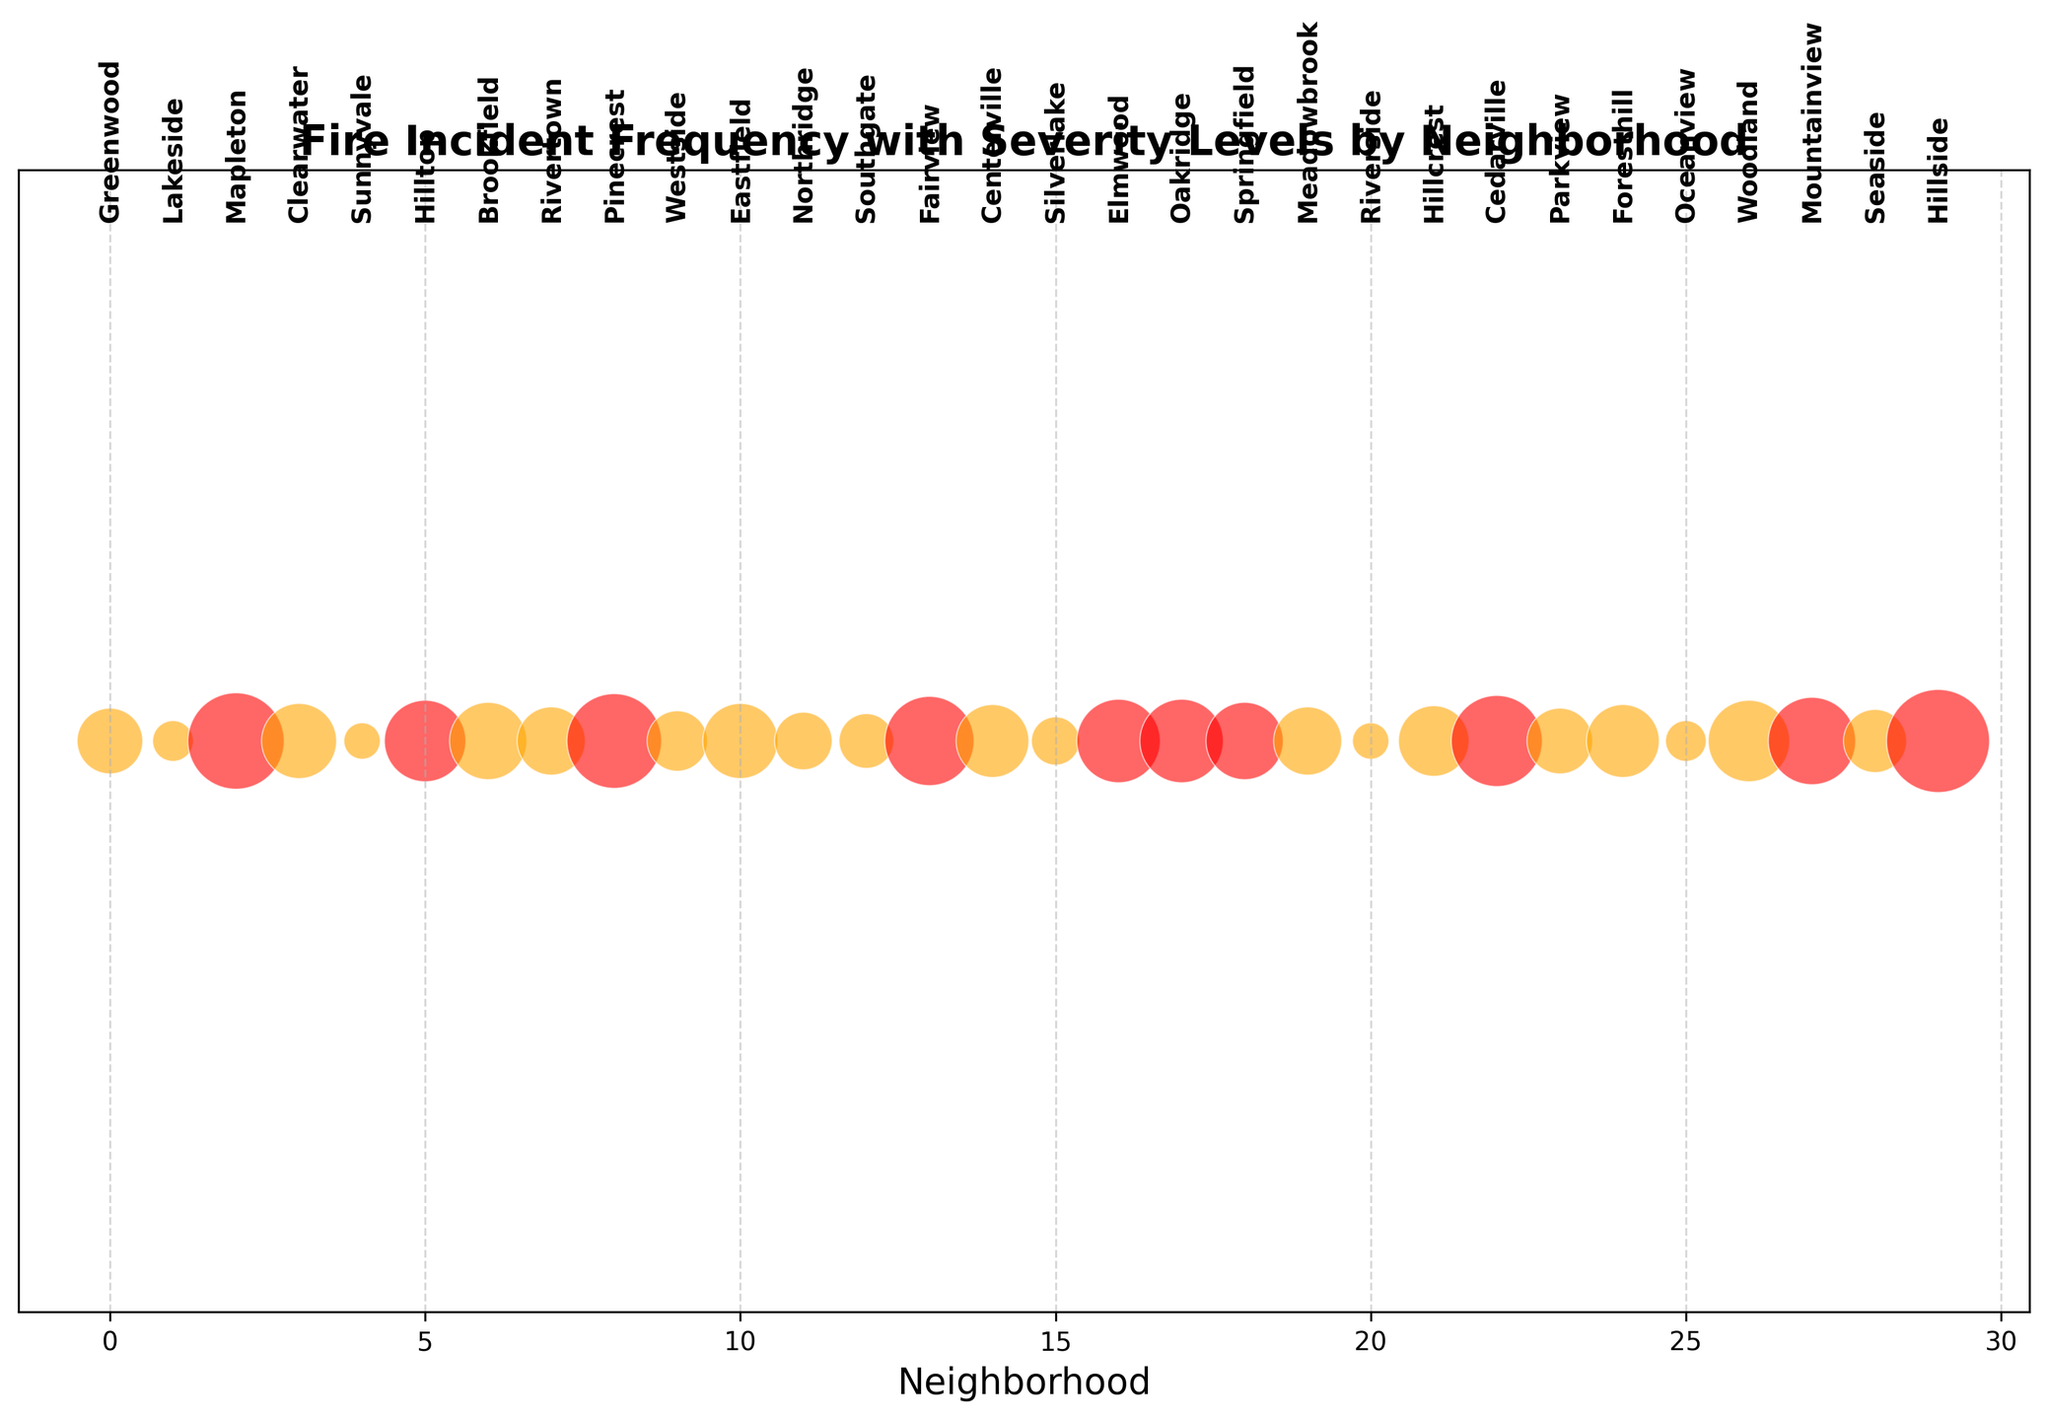What's the neighborhood with the largest bubble? The largest bubble represents Hillside, indicating it has the highest combined frequency of fire incidents across all severities. One can deduce this from the figure by looking for the biggest circle, which corresponds to Hillside.
Answer: Hillside Which neighborhoods have red-colored bubbles? Red-colored bubbles indicate high-severity incidents greater than 1. By inspecting the figure, the neighborhoods with red bubbles are Elmwood, Oakridge, Mountainview, Hillside, and Hillside.
Answer: Elmwood, Oakridge, Mountainview, Hillside Is the bubble size of Mapleton larger than Cedarville? Comparing the visual sizes of the bubbles for Mapleton and Cedarville, Mapleton's bubble is larger, indicating a higher frequency or severity of fire incidents.
Answer: Yes Which neighborhoods have the smallest bubbles? The smallest bubbles are observed in neighborhoods with the least combined frequency of severity, such as Lakeside and Sunnyvale. These are the smallest bubbles on the plot.
Answer: Lakeside, Sunnyvale How many neighborhoods have exactly four bubbles in size based on fire incidents? By observing the figure carefully, only Hillside has a combined four incidents across all severity levels. This can be inferred by counting the combined size of the bubble.
Answer: One Which neighborhood has more high-severity incidents, Greenwood or Clearwater? By comparing the bubbles' visual attributes and text labels, Greenwood has 2 high-severity incidents, while Clearwater has 1 high-severity incident.
Answer: Greenwood Are there more neighborhoods with zero or exactly one high-severity incidents? From the figure, counting the neighborhoods with zero high-severity incidents (e.g., Lakeside, Sunnyvale, Southgate, Riverside, Oceanview), and counting those with exactly one (e.g., Greenwood, Brookfield, Rivertown, Eastfield, Northridge, Meadowbrook, Westside, Cedarville, Forresthill, Centerville, Woodland, Seaside, Hilltop, Parkview), there are visibly more neighborhoods with exactly one high-severity incidents.
Answer: Exactly one high-severity incidents Which neighborhood has the most moderate-severity incidents, and how many are there? By looking at the sizes and labels of the bubbles, Hillside shows the largest moderate-severity bubble. Observing the visual size differences aids in concluding there are 5 moderate-severity incidents.
Answer: Hillside, 5 Compare the combined fire incidents (adding low, moderate, and high severity) of Northridge and Brookfield. Which is higher? Adding the incidents for Northridge (4+1+1=6) and Brookfield (6+4+1=11) and comparing, Brookfield has higher combined incidents.
Answer: Brookfield Which neighborhoods have a combination of low and high-severity incidents? Observing the color and size details of bubbles, examples include Greenwood, Rivertown, and Westside, as these bubbles visually indicate the presence of both low and high-severity incidents respectively.
Answer: Greenwood, Rivertown, Westside 